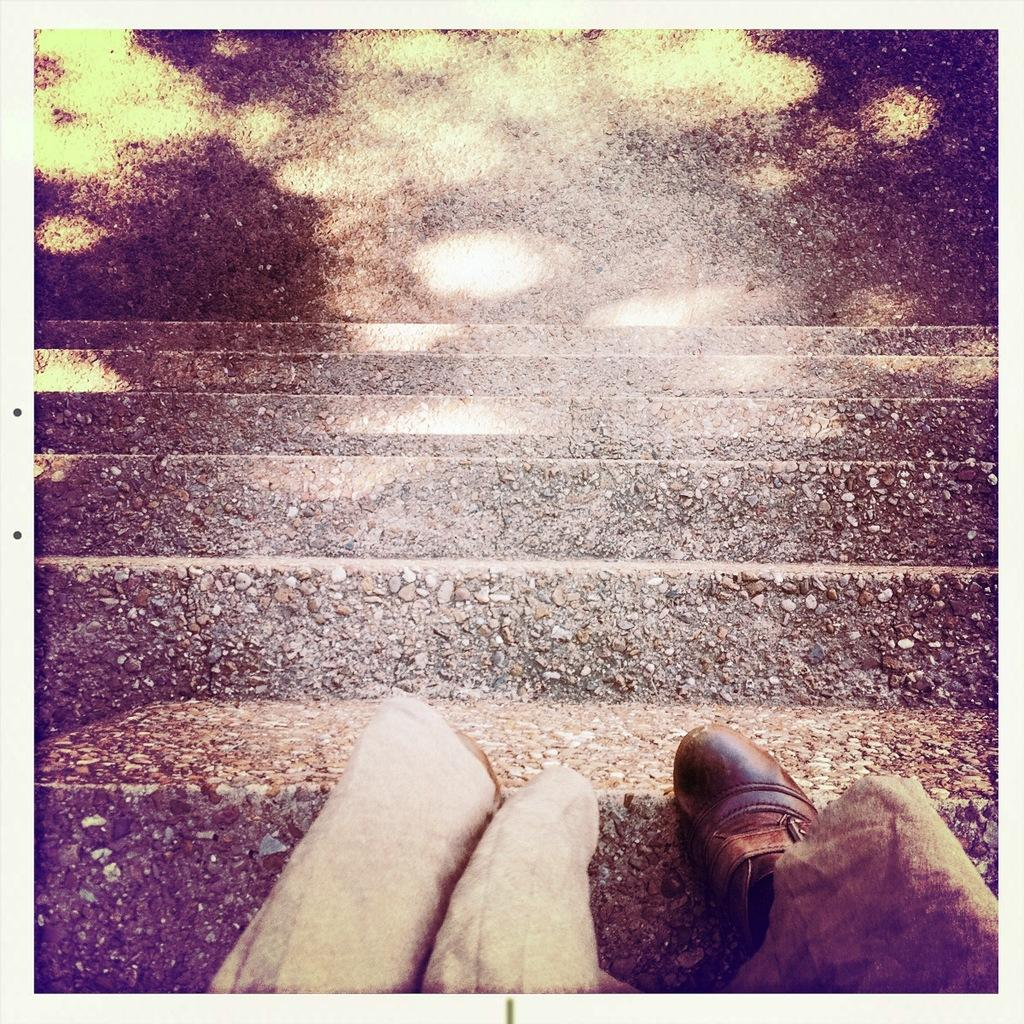What part of a person can be seen in the image? There are legs of a person visible in the image. Where are the legs located in the image? The legs are on a staircase. What type of bulb is being used to light up the feast in the image? There is no feast or bulb present in the image; it only shows legs on a staircase. 